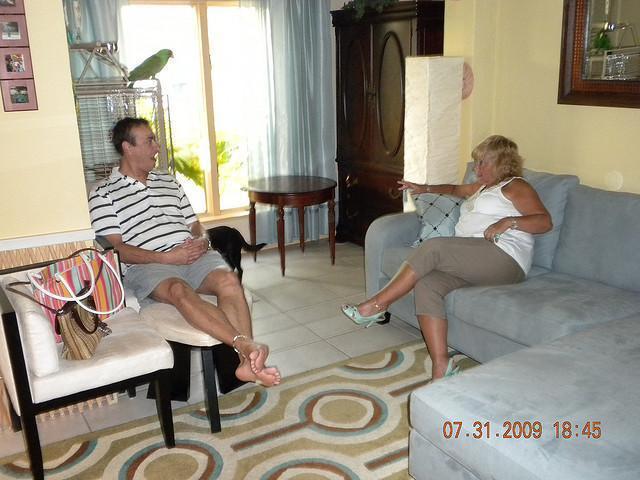How many people are there?
Give a very brief answer. 2. How many chairs are there?
Give a very brief answer. 2. 